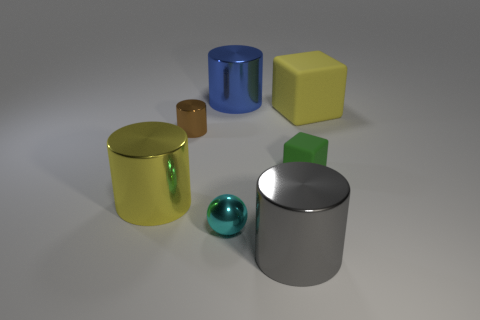There is a shiny thing that is the same color as the large cube; what is its size?
Offer a very short reply. Large. There is another thing that is the same shape as the tiny green thing; what size is it?
Offer a very short reply. Large. Are there an equal number of big blocks on the left side of the big rubber cube and tiny purple cylinders?
Your response must be concise. Yes. Do the large object behind the yellow rubber block and the large yellow object that is on the right side of the big yellow shiny thing have the same material?
Your answer should be compact. No. How many objects are either brown cylinders or objects that are on the right side of the big gray cylinder?
Offer a very short reply. 3. Are there any tiny shiny things that have the same shape as the big gray thing?
Keep it short and to the point. Yes. There is a metal cylinder that is in front of the large metal cylinder on the left side of the big shiny cylinder that is behind the big yellow matte block; what size is it?
Make the answer very short. Large. Are there an equal number of matte objects that are on the right side of the green object and tiny green blocks that are to the left of the big yellow matte thing?
Make the answer very short. Yes. There is a brown cylinder that is the same material as the sphere; what is its size?
Offer a terse response. Small. What color is the sphere?
Your response must be concise. Cyan. 